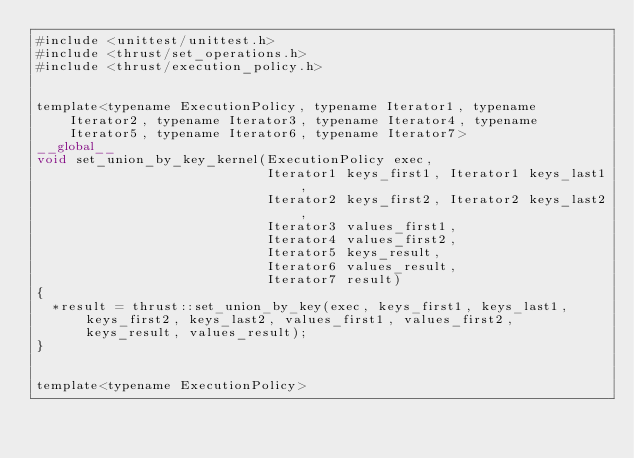<code> <loc_0><loc_0><loc_500><loc_500><_Cuda_>#include <unittest/unittest.h>
#include <thrust/set_operations.h>
#include <thrust/execution_policy.h>


template<typename ExecutionPolicy, typename Iterator1, typename Iterator2, typename Iterator3, typename Iterator4, typename Iterator5, typename Iterator6, typename Iterator7>
__global__
void set_union_by_key_kernel(ExecutionPolicy exec,
                             Iterator1 keys_first1, Iterator1 keys_last1,
                             Iterator2 keys_first2, Iterator2 keys_last2,
                             Iterator3 values_first1,
                             Iterator4 values_first2,
                             Iterator5 keys_result,
                             Iterator6 values_result,
                             Iterator7 result)
{
  *result = thrust::set_union_by_key(exec, keys_first1, keys_last1, keys_first2, keys_last2, values_first1, values_first2, keys_result, values_result);
}


template<typename ExecutionPolicy></code> 